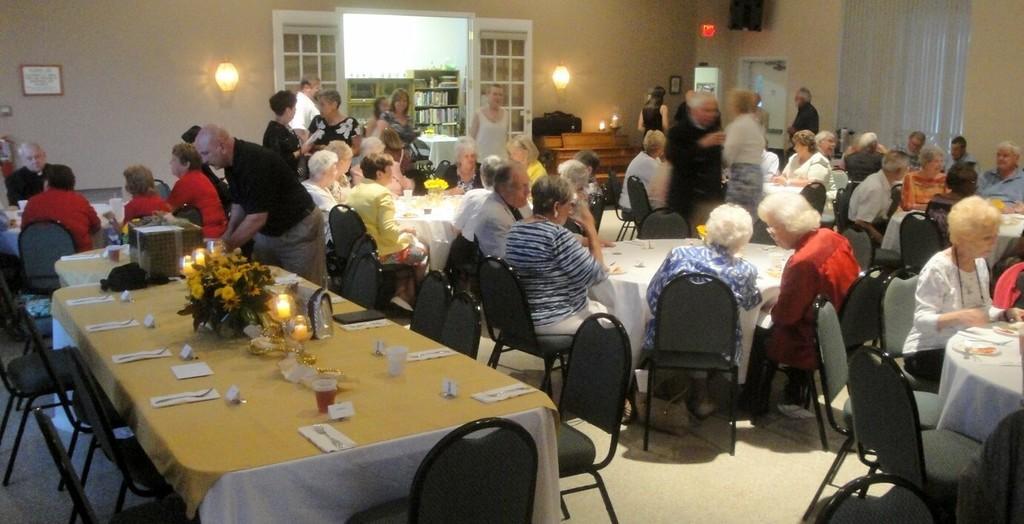In one or two sentences, can you explain what this image depicts? There are many people sat on chairs around the table. There are curtains on to the right side of the wall and a door in the middle and there are two lights on either sides of the door. The table has flowers glass. The most people over here is seems to be of old age. 